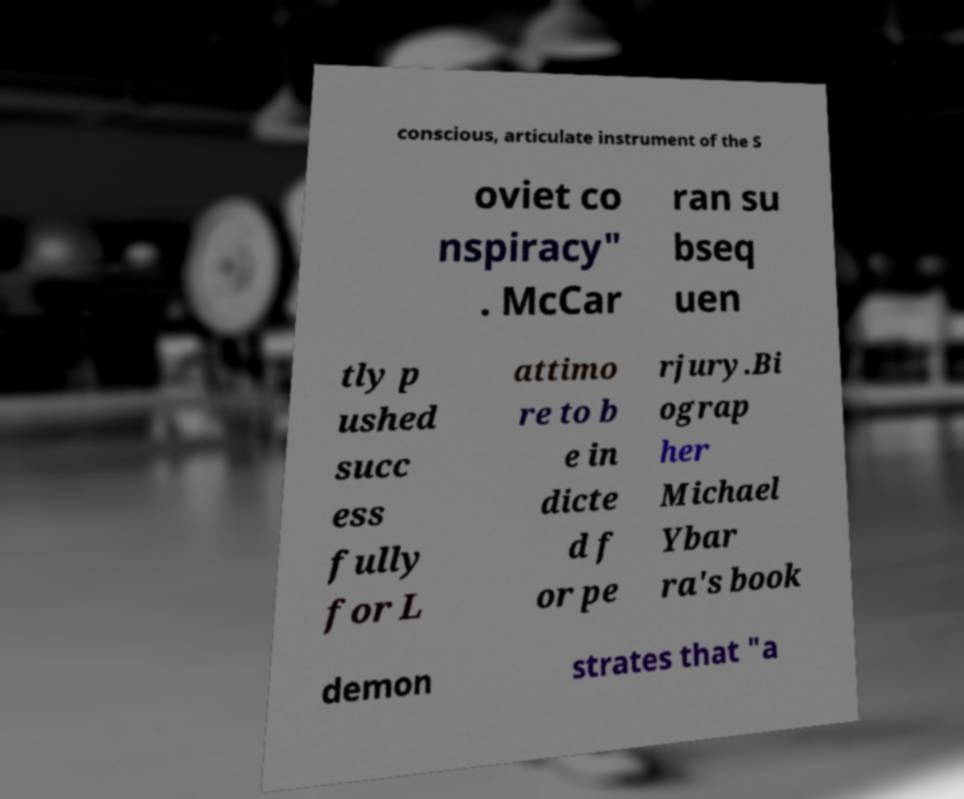Please identify and transcribe the text found in this image. conscious, articulate instrument of the S oviet co nspiracy" . McCar ran su bseq uen tly p ushed succ ess fully for L attimo re to b e in dicte d f or pe rjury.Bi ograp her Michael Ybar ra's book demon strates that "a 